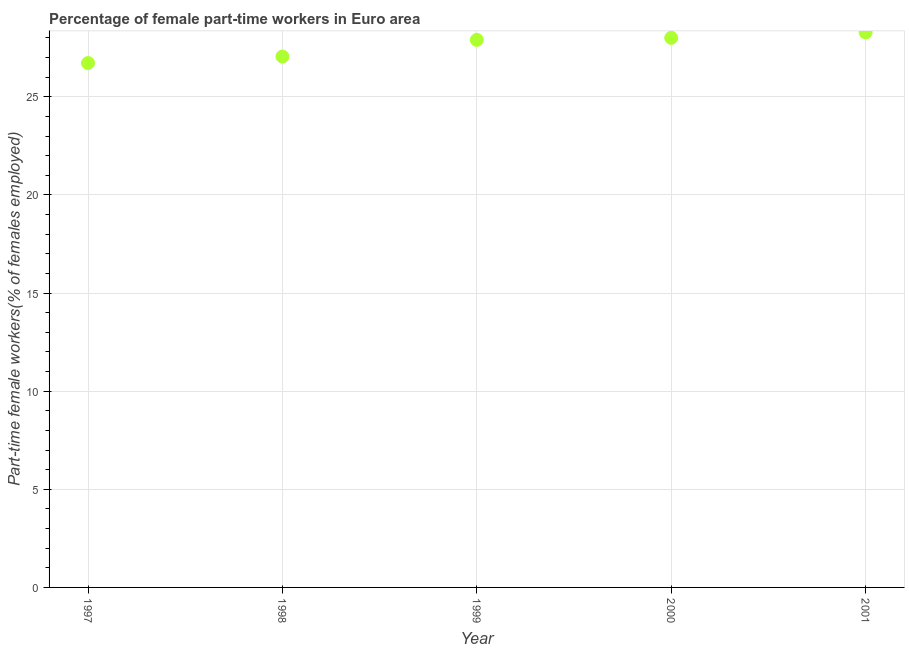What is the percentage of part-time female workers in 1997?
Ensure brevity in your answer.  26.72. Across all years, what is the maximum percentage of part-time female workers?
Provide a succinct answer. 28.28. Across all years, what is the minimum percentage of part-time female workers?
Your response must be concise. 26.72. In which year was the percentage of part-time female workers minimum?
Your response must be concise. 1997. What is the sum of the percentage of part-time female workers?
Ensure brevity in your answer.  137.96. What is the difference between the percentage of part-time female workers in 1998 and 2001?
Provide a short and direct response. -1.23. What is the average percentage of part-time female workers per year?
Offer a terse response. 27.59. What is the median percentage of part-time female workers?
Your answer should be very brief. 27.9. Do a majority of the years between 1999 and 2000 (inclusive) have percentage of part-time female workers greater than 17 %?
Your response must be concise. Yes. What is the ratio of the percentage of part-time female workers in 1999 to that in 2001?
Your answer should be very brief. 0.99. What is the difference between the highest and the second highest percentage of part-time female workers?
Your answer should be compact. 0.28. Is the sum of the percentage of part-time female workers in 1997 and 2000 greater than the maximum percentage of part-time female workers across all years?
Your answer should be very brief. Yes. What is the difference between the highest and the lowest percentage of part-time female workers?
Your answer should be very brief. 1.56. How many dotlines are there?
Provide a short and direct response. 1. Are the values on the major ticks of Y-axis written in scientific E-notation?
Keep it short and to the point. No. Does the graph contain grids?
Provide a succinct answer. Yes. What is the title of the graph?
Your answer should be compact. Percentage of female part-time workers in Euro area. What is the label or title of the X-axis?
Give a very brief answer. Year. What is the label or title of the Y-axis?
Your response must be concise. Part-time female workers(% of females employed). What is the Part-time female workers(% of females employed) in 1997?
Ensure brevity in your answer.  26.72. What is the Part-time female workers(% of females employed) in 1998?
Provide a short and direct response. 27.05. What is the Part-time female workers(% of females employed) in 1999?
Keep it short and to the point. 27.9. What is the Part-time female workers(% of females employed) in 2000?
Your answer should be compact. 28.01. What is the Part-time female workers(% of females employed) in 2001?
Your answer should be very brief. 28.28. What is the difference between the Part-time female workers(% of females employed) in 1997 and 1998?
Ensure brevity in your answer.  -0.33. What is the difference between the Part-time female workers(% of females employed) in 1997 and 1999?
Offer a terse response. -1.18. What is the difference between the Part-time female workers(% of females employed) in 1997 and 2000?
Provide a short and direct response. -1.28. What is the difference between the Part-time female workers(% of females employed) in 1997 and 2001?
Offer a terse response. -1.56. What is the difference between the Part-time female workers(% of females employed) in 1998 and 1999?
Provide a short and direct response. -0.85. What is the difference between the Part-time female workers(% of females employed) in 1998 and 2000?
Offer a very short reply. -0.95. What is the difference between the Part-time female workers(% of females employed) in 1998 and 2001?
Ensure brevity in your answer.  -1.23. What is the difference between the Part-time female workers(% of females employed) in 1999 and 2000?
Provide a succinct answer. -0.1. What is the difference between the Part-time female workers(% of females employed) in 1999 and 2001?
Provide a succinct answer. -0.38. What is the difference between the Part-time female workers(% of females employed) in 2000 and 2001?
Offer a terse response. -0.28. What is the ratio of the Part-time female workers(% of females employed) in 1997 to that in 1998?
Your answer should be very brief. 0.99. What is the ratio of the Part-time female workers(% of females employed) in 1997 to that in 1999?
Keep it short and to the point. 0.96. What is the ratio of the Part-time female workers(% of females employed) in 1997 to that in 2000?
Ensure brevity in your answer.  0.95. What is the ratio of the Part-time female workers(% of females employed) in 1997 to that in 2001?
Keep it short and to the point. 0.94. What is the ratio of the Part-time female workers(% of females employed) in 1998 to that in 2000?
Provide a short and direct response. 0.97. What is the ratio of the Part-time female workers(% of females employed) in 1998 to that in 2001?
Give a very brief answer. 0.96. What is the ratio of the Part-time female workers(% of females employed) in 1999 to that in 2001?
Ensure brevity in your answer.  0.99. What is the ratio of the Part-time female workers(% of females employed) in 2000 to that in 2001?
Give a very brief answer. 0.99. 